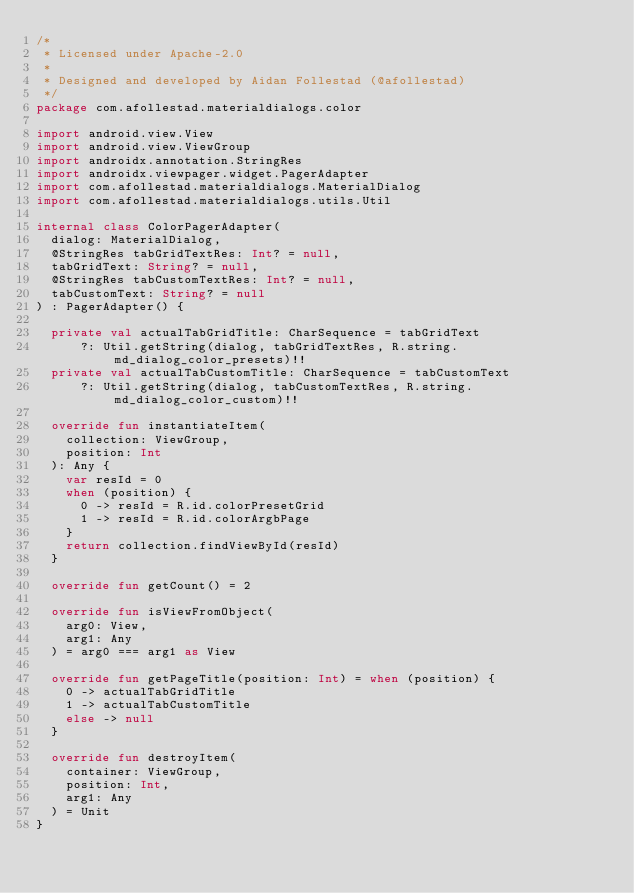Convert code to text. <code><loc_0><loc_0><loc_500><loc_500><_Kotlin_>/*
 * Licensed under Apache-2.0
 *
 * Designed and developed by Aidan Follestad (@afollestad)
 */
package com.afollestad.materialdialogs.color

import android.view.View
import android.view.ViewGroup
import androidx.annotation.StringRes
import androidx.viewpager.widget.PagerAdapter
import com.afollestad.materialdialogs.MaterialDialog
import com.afollestad.materialdialogs.utils.Util

internal class ColorPagerAdapter(
  dialog: MaterialDialog,
  @StringRes tabGridTextRes: Int? = null,
  tabGridText: String? = null,
  @StringRes tabCustomTextRes: Int? = null,
  tabCustomText: String? = null
) : PagerAdapter() {

  private val actualTabGridTitle: CharSequence = tabGridText
      ?: Util.getString(dialog, tabGridTextRes, R.string.md_dialog_color_presets)!!
  private val actualTabCustomTitle: CharSequence = tabCustomText
      ?: Util.getString(dialog, tabCustomTextRes, R.string.md_dialog_color_custom)!!

  override fun instantiateItem(
    collection: ViewGroup,
    position: Int
  ): Any {
    var resId = 0
    when (position) {
      0 -> resId = R.id.colorPresetGrid
      1 -> resId = R.id.colorArgbPage
    }
    return collection.findViewById(resId)
  }

  override fun getCount() = 2

  override fun isViewFromObject(
    arg0: View,
    arg1: Any
  ) = arg0 === arg1 as View

  override fun getPageTitle(position: Int) = when (position) {
    0 -> actualTabGridTitle
    1 -> actualTabCustomTitle
    else -> null
  }

  override fun destroyItem(
    container: ViewGroup,
    position: Int,
    arg1: Any
  ) = Unit
}
</code> 